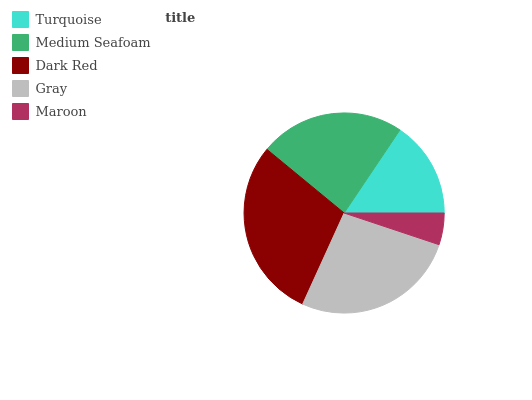Is Maroon the minimum?
Answer yes or no. Yes. Is Dark Red the maximum?
Answer yes or no. Yes. Is Medium Seafoam the minimum?
Answer yes or no. No. Is Medium Seafoam the maximum?
Answer yes or no. No. Is Medium Seafoam greater than Turquoise?
Answer yes or no. Yes. Is Turquoise less than Medium Seafoam?
Answer yes or no. Yes. Is Turquoise greater than Medium Seafoam?
Answer yes or no. No. Is Medium Seafoam less than Turquoise?
Answer yes or no. No. Is Medium Seafoam the high median?
Answer yes or no. Yes. Is Medium Seafoam the low median?
Answer yes or no. Yes. Is Gray the high median?
Answer yes or no. No. Is Dark Red the low median?
Answer yes or no. No. 